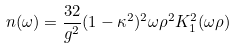Convert formula to latex. <formula><loc_0><loc_0><loc_500><loc_500>n ( \omega ) = \frac { 3 2 } { g ^ { 2 } } ( { 1 - \kappa ^ { 2 } } ) ^ { 2 } \omega \rho ^ { 2 } K _ { 1 } ^ { 2 } ( \omega \rho )</formula> 